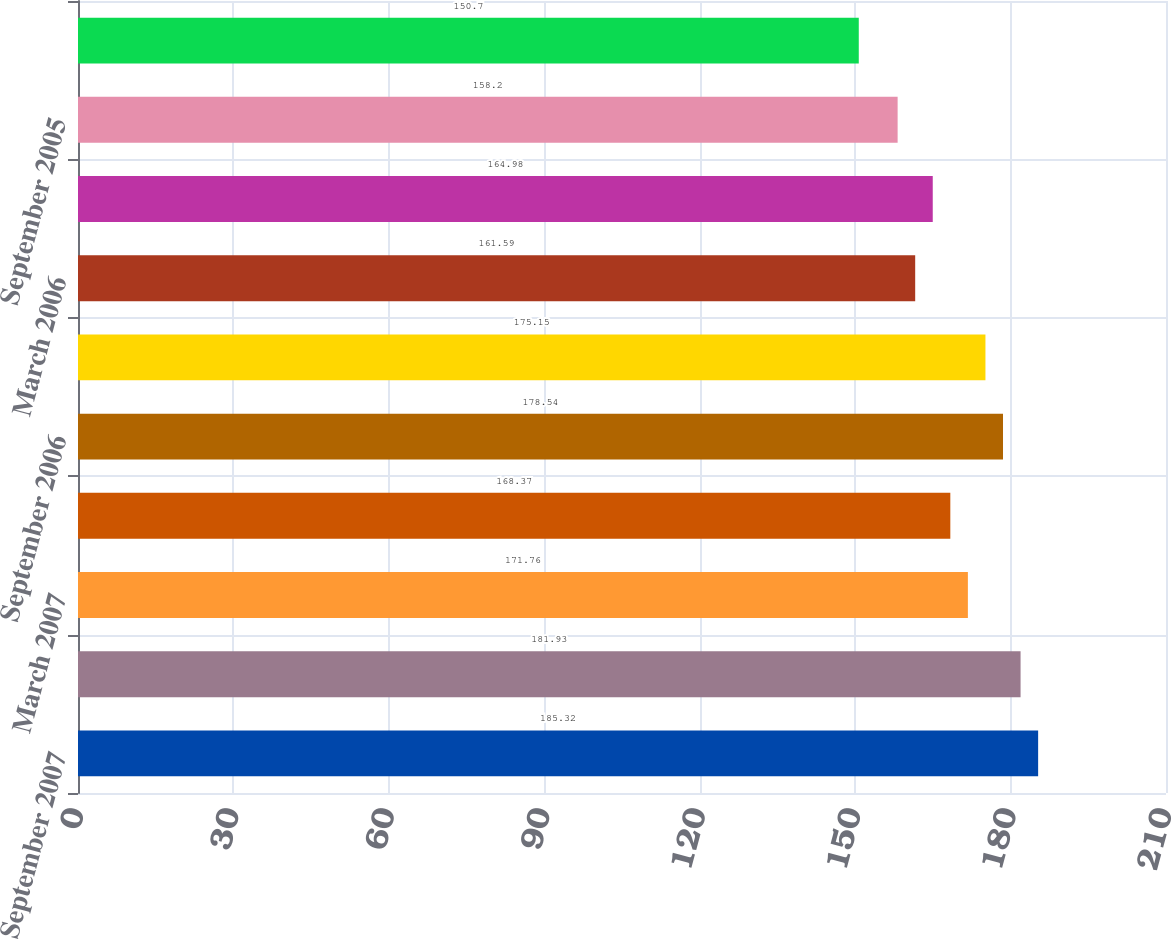Convert chart. <chart><loc_0><loc_0><loc_500><loc_500><bar_chart><fcel>September 2007<fcel>June 2007<fcel>March 2007<fcel>December 2006<fcel>September 2006<fcel>June 2006<fcel>March 2006<fcel>December 2005<fcel>September 2005<fcel>June 2005<nl><fcel>185.32<fcel>181.93<fcel>171.76<fcel>168.37<fcel>178.54<fcel>175.15<fcel>161.59<fcel>164.98<fcel>158.2<fcel>150.7<nl></chart> 